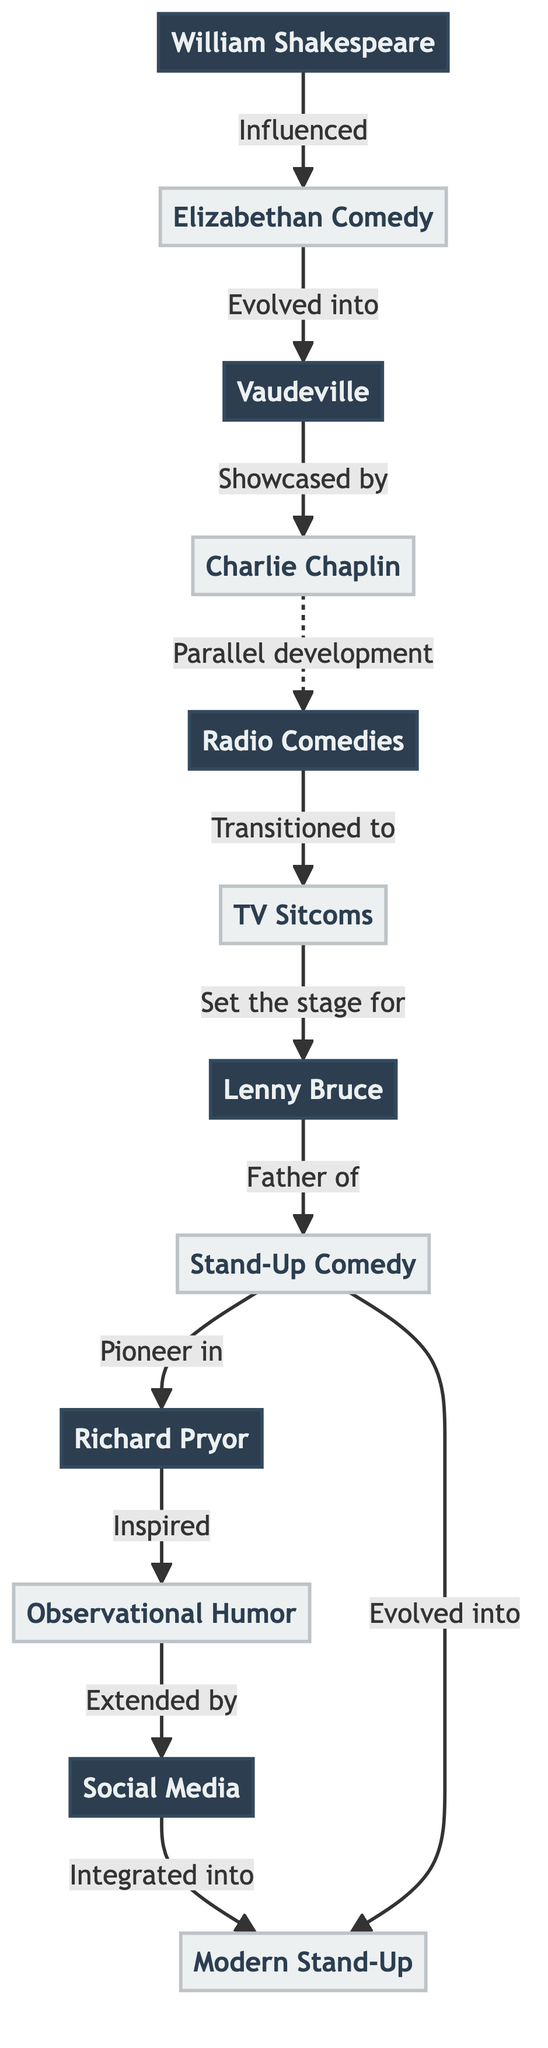What is the first node in the diagram? The first node in the diagram is William Shakespeare, as indicated at the top of the flow.
Answer: William Shakespeare How many nodes are present in the diagram? By counting the unique entities listed in the diagram, there are 12 nodes in total.
Answer: 12 What are the two comedic styles that evolved directly from Elizabethan Comedy? From the diagram, Elizabethan Comedy evolved into Vaudeville and Shakespeare influenced it.
Answer: Vaudeville and Shakespeare Who is labeled as the 'Father of' modern Stand-Up Comedy in the diagram? The diagram designates Lenny Bruce as the 'Father of' modern Stand-Up Comedy based on the directed edge from him to Stand-Up Comedy.
Answer: Lenny Bruce Which comedic format transitioned into TV Sitcoms according to the diagram? Radio Comedies transitioned into TV Sitcoms as shown by the directed edge leading from Radio Comedies to TV Sitcoms.
Answer: Radio Comedies What is the relationship between Richard Pryor and Observational Humor? The diagram indicates that Richard Pryor inspired Observational Humor, shown by an edge from Richard Pryor to Observational Humor.
Answer: Inspired Which two nodes are connected by the label 'Evolved into'? The nodes connected by the label 'Evolved into' are Stand-Up Comedy and Modern Stand-Up, indicating that Stand-Up Comedy evolved into Modern Stand-Up.
Answer: Stand-Up Comedy and Modern Stand-Up What medium amplified the reach of comedians as represented in the diagram? The diagram shows that Social Media amplified the reach of comedians and their jokes, as denoted by the directed edge leading to Modern Stand-Up.
Answer: Social Media Which comedic form showcased the work of Charlie Chaplin? Vaudeville is the comedic form that showcased Charlie Chaplin's work, highlighted by the connection from Vaudeville to Charlie Chaplin in the diagram.
Answer: Vaudeville 